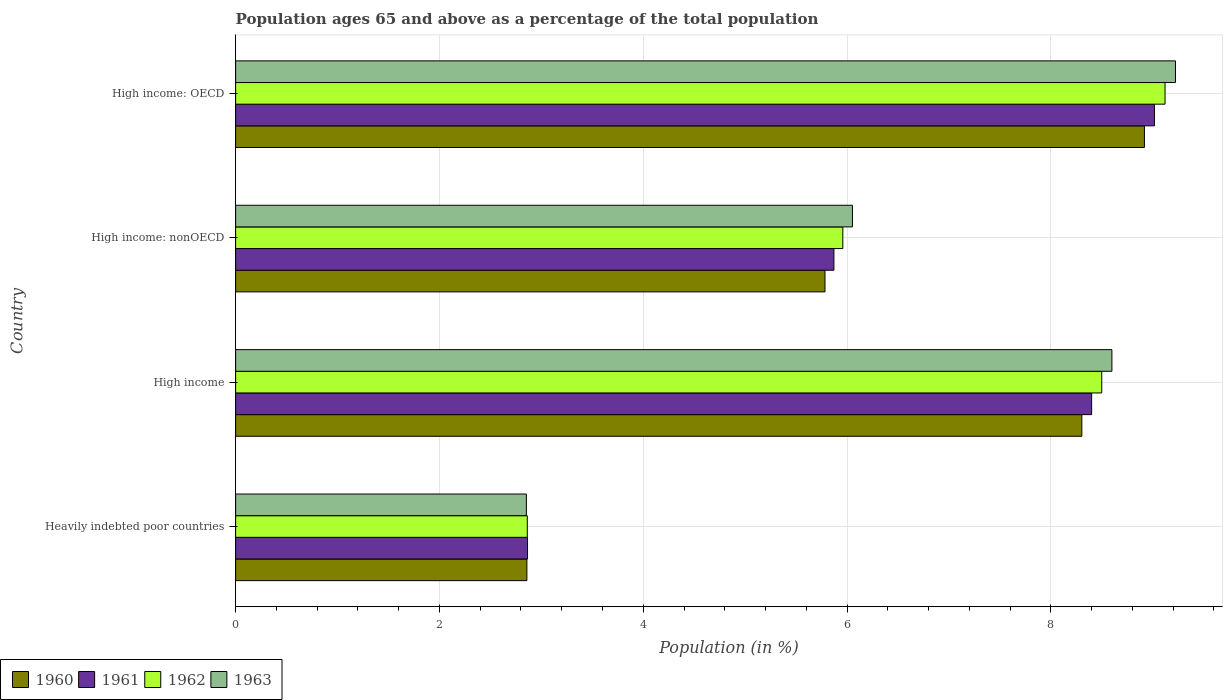Are the number of bars per tick equal to the number of legend labels?
Provide a succinct answer. Yes. Are the number of bars on each tick of the Y-axis equal?
Offer a very short reply. Yes. How many bars are there on the 2nd tick from the top?
Keep it short and to the point. 4. How many bars are there on the 3rd tick from the bottom?
Give a very brief answer. 4. What is the label of the 3rd group of bars from the top?
Make the answer very short. High income. What is the percentage of the population ages 65 and above in 1962 in High income: nonOECD?
Provide a succinct answer. 5.96. Across all countries, what is the maximum percentage of the population ages 65 and above in 1960?
Ensure brevity in your answer.  8.92. Across all countries, what is the minimum percentage of the population ages 65 and above in 1962?
Your answer should be compact. 2.86. In which country was the percentage of the population ages 65 and above in 1962 maximum?
Provide a short and direct response. High income: OECD. In which country was the percentage of the population ages 65 and above in 1963 minimum?
Offer a very short reply. Heavily indebted poor countries. What is the total percentage of the population ages 65 and above in 1962 in the graph?
Provide a succinct answer. 26.44. What is the difference between the percentage of the population ages 65 and above in 1960 in Heavily indebted poor countries and that in High income?
Provide a short and direct response. -5.45. What is the difference between the percentage of the population ages 65 and above in 1960 in High income and the percentage of the population ages 65 and above in 1963 in High income: nonOECD?
Your response must be concise. 2.25. What is the average percentage of the population ages 65 and above in 1960 per country?
Make the answer very short. 6.47. What is the difference between the percentage of the population ages 65 and above in 1960 and percentage of the population ages 65 and above in 1962 in High income: OECD?
Your response must be concise. -0.2. What is the ratio of the percentage of the population ages 65 and above in 1963 in High income to that in High income: OECD?
Your answer should be very brief. 0.93. Is the percentage of the population ages 65 and above in 1960 in High income: OECD less than that in High income: nonOECD?
Your answer should be compact. No. Is the difference between the percentage of the population ages 65 and above in 1960 in Heavily indebted poor countries and High income greater than the difference between the percentage of the population ages 65 and above in 1962 in Heavily indebted poor countries and High income?
Keep it short and to the point. Yes. What is the difference between the highest and the second highest percentage of the population ages 65 and above in 1963?
Provide a succinct answer. 0.62. What is the difference between the highest and the lowest percentage of the population ages 65 and above in 1963?
Offer a terse response. 6.37. In how many countries, is the percentage of the population ages 65 and above in 1961 greater than the average percentage of the population ages 65 and above in 1961 taken over all countries?
Ensure brevity in your answer.  2. Is it the case that in every country, the sum of the percentage of the population ages 65 and above in 1961 and percentage of the population ages 65 and above in 1963 is greater than the sum of percentage of the population ages 65 and above in 1960 and percentage of the population ages 65 and above in 1962?
Make the answer very short. No. Is it the case that in every country, the sum of the percentage of the population ages 65 and above in 1962 and percentage of the population ages 65 and above in 1960 is greater than the percentage of the population ages 65 and above in 1963?
Your answer should be compact. Yes. How many bars are there?
Offer a very short reply. 16. Are all the bars in the graph horizontal?
Ensure brevity in your answer.  Yes. How many countries are there in the graph?
Your response must be concise. 4. Does the graph contain grids?
Your answer should be very brief. Yes. How many legend labels are there?
Your answer should be very brief. 4. What is the title of the graph?
Provide a succinct answer. Population ages 65 and above as a percentage of the total population. Does "1960" appear as one of the legend labels in the graph?
Offer a terse response. Yes. What is the label or title of the X-axis?
Offer a terse response. Population (in %). What is the label or title of the Y-axis?
Your response must be concise. Country. What is the Population (in %) in 1960 in Heavily indebted poor countries?
Your answer should be compact. 2.86. What is the Population (in %) in 1961 in Heavily indebted poor countries?
Your answer should be compact. 2.86. What is the Population (in %) in 1962 in Heavily indebted poor countries?
Offer a very short reply. 2.86. What is the Population (in %) in 1963 in Heavily indebted poor countries?
Your answer should be very brief. 2.85. What is the Population (in %) in 1960 in High income?
Your answer should be compact. 8.3. What is the Population (in %) of 1961 in High income?
Your response must be concise. 8.4. What is the Population (in %) of 1962 in High income?
Offer a terse response. 8.5. What is the Population (in %) in 1963 in High income?
Ensure brevity in your answer.  8.6. What is the Population (in %) of 1960 in High income: nonOECD?
Keep it short and to the point. 5.78. What is the Population (in %) of 1961 in High income: nonOECD?
Your answer should be compact. 5.87. What is the Population (in %) of 1962 in High income: nonOECD?
Your answer should be very brief. 5.96. What is the Population (in %) in 1963 in High income: nonOECD?
Your answer should be compact. 6.05. What is the Population (in %) in 1960 in High income: OECD?
Give a very brief answer. 8.92. What is the Population (in %) of 1961 in High income: OECD?
Keep it short and to the point. 9.02. What is the Population (in %) in 1962 in High income: OECD?
Offer a very short reply. 9.12. What is the Population (in %) of 1963 in High income: OECD?
Provide a succinct answer. 9.22. Across all countries, what is the maximum Population (in %) of 1960?
Make the answer very short. 8.92. Across all countries, what is the maximum Population (in %) of 1961?
Your answer should be compact. 9.02. Across all countries, what is the maximum Population (in %) in 1962?
Offer a very short reply. 9.12. Across all countries, what is the maximum Population (in %) in 1963?
Offer a terse response. 9.22. Across all countries, what is the minimum Population (in %) in 1960?
Offer a very short reply. 2.86. Across all countries, what is the minimum Population (in %) in 1961?
Keep it short and to the point. 2.86. Across all countries, what is the minimum Population (in %) in 1962?
Give a very brief answer. 2.86. Across all countries, what is the minimum Population (in %) of 1963?
Make the answer very short. 2.85. What is the total Population (in %) of 1960 in the graph?
Your response must be concise. 25.86. What is the total Population (in %) in 1961 in the graph?
Your answer should be very brief. 26.15. What is the total Population (in %) of 1962 in the graph?
Give a very brief answer. 26.44. What is the total Population (in %) in 1963 in the graph?
Provide a short and direct response. 26.73. What is the difference between the Population (in %) of 1960 in Heavily indebted poor countries and that in High income?
Offer a terse response. -5.45. What is the difference between the Population (in %) of 1961 in Heavily indebted poor countries and that in High income?
Offer a terse response. -5.54. What is the difference between the Population (in %) of 1962 in Heavily indebted poor countries and that in High income?
Give a very brief answer. -5.64. What is the difference between the Population (in %) of 1963 in Heavily indebted poor countries and that in High income?
Give a very brief answer. -5.75. What is the difference between the Population (in %) of 1960 in Heavily indebted poor countries and that in High income: nonOECD?
Your answer should be compact. -2.92. What is the difference between the Population (in %) in 1961 in Heavily indebted poor countries and that in High income: nonOECD?
Your response must be concise. -3.01. What is the difference between the Population (in %) of 1962 in Heavily indebted poor countries and that in High income: nonOECD?
Your answer should be compact. -3.1. What is the difference between the Population (in %) of 1963 in Heavily indebted poor countries and that in High income: nonOECD?
Provide a short and direct response. -3.2. What is the difference between the Population (in %) of 1960 in Heavily indebted poor countries and that in High income: OECD?
Offer a terse response. -6.06. What is the difference between the Population (in %) of 1961 in Heavily indebted poor countries and that in High income: OECD?
Offer a terse response. -6.15. What is the difference between the Population (in %) in 1962 in Heavily indebted poor countries and that in High income: OECD?
Your answer should be compact. -6.26. What is the difference between the Population (in %) in 1963 in Heavily indebted poor countries and that in High income: OECD?
Give a very brief answer. -6.37. What is the difference between the Population (in %) in 1960 in High income and that in High income: nonOECD?
Keep it short and to the point. 2.52. What is the difference between the Population (in %) in 1961 in High income and that in High income: nonOECD?
Your answer should be very brief. 2.53. What is the difference between the Population (in %) in 1962 in High income and that in High income: nonOECD?
Your response must be concise. 2.54. What is the difference between the Population (in %) in 1963 in High income and that in High income: nonOECD?
Your answer should be compact. 2.55. What is the difference between the Population (in %) in 1960 in High income and that in High income: OECD?
Your answer should be compact. -0.61. What is the difference between the Population (in %) in 1961 in High income and that in High income: OECD?
Your answer should be very brief. -0.62. What is the difference between the Population (in %) of 1962 in High income and that in High income: OECD?
Give a very brief answer. -0.62. What is the difference between the Population (in %) in 1963 in High income and that in High income: OECD?
Make the answer very short. -0.62. What is the difference between the Population (in %) of 1960 in High income: nonOECD and that in High income: OECD?
Keep it short and to the point. -3.13. What is the difference between the Population (in %) of 1961 in High income: nonOECD and that in High income: OECD?
Your answer should be very brief. -3.15. What is the difference between the Population (in %) in 1962 in High income: nonOECD and that in High income: OECD?
Make the answer very short. -3.16. What is the difference between the Population (in %) in 1963 in High income: nonOECD and that in High income: OECD?
Keep it short and to the point. -3.17. What is the difference between the Population (in %) of 1960 in Heavily indebted poor countries and the Population (in %) of 1961 in High income?
Provide a short and direct response. -5.54. What is the difference between the Population (in %) of 1960 in Heavily indebted poor countries and the Population (in %) of 1962 in High income?
Offer a very short reply. -5.64. What is the difference between the Population (in %) in 1960 in Heavily indebted poor countries and the Population (in %) in 1963 in High income?
Offer a very short reply. -5.74. What is the difference between the Population (in %) in 1961 in Heavily indebted poor countries and the Population (in %) in 1962 in High income?
Offer a very short reply. -5.63. What is the difference between the Population (in %) of 1961 in Heavily indebted poor countries and the Population (in %) of 1963 in High income?
Ensure brevity in your answer.  -5.73. What is the difference between the Population (in %) in 1962 in Heavily indebted poor countries and the Population (in %) in 1963 in High income?
Offer a terse response. -5.74. What is the difference between the Population (in %) of 1960 in Heavily indebted poor countries and the Population (in %) of 1961 in High income: nonOECD?
Make the answer very short. -3.01. What is the difference between the Population (in %) of 1960 in Heavily indebted poor countries and the Population (in %) of 1962 in High income: nonOECD?
Give a very brief answer. -3.1. What is the difference between the Population (in %) of 1960 in Heavily indebted poor countries and the Population (in %) of 1963 in High income: nonOECD?
Provide a succinct answer. -3.19. What is the difference between the Population (in %) in 1961 in Heavily indebted poor countries and the Population (in %) in 1962 in High income: nonOECD?
Your answer should be compact. -3.09. What is the difference between the Population (in %) of 1961 in Heavily indebted poor countries and the Population (in %) of 1963 in High income: nonOECD?
Give a very brief answer. -3.19. What is the difference between the Population (in %) of 1962 in Heavily indebted poor countries and the Population (in %) of 1963 in High income: nonOECD?
Provide a short and direct response. -3.19. What is the difference between the Population (in %) in 1960 in Heavily indebted poor countries and the Population (in %) in 1961 in High income: OECD?
Provide a short and direct response. -6.16. What is the difference between the Population (in %) in 1960 in Heavily indebted poor countries and the Population (in %) in 1962 in High income: OECD?
Your answer should be very brief. -6.26. What is the difference between the Population (in %) of 1960 in Heavily indebted poor countries and the Population (in %) of 1963 in High income: OECD?
Provide a short and direct response. -6.36. What is the difference between the Population (in %) of 1961 in Heavily indebted poor countries and the Population (in %) of 1962 in High income: OECD?
Make the answer very short. -6.26. What is the difference between the Population (in %) of 1961 in Heavily indebted poor countries and the Population (in %) of 1963 in High income: OECD?
Keep it short and to the point. -6.36. What is the difference between the Population (in %) in 1962 in Heavily indebted poor countries and the Population (in %) in 1963 in High income: OECD?
Your answer should be very brief. -6.36. What is the difference between the Population (in %) of 1960 in High income and the Population (in %) of 1961 in High income: nonOECD?
Keep it short and to the point. 2.43. What is the difference between the Population (in %) of 1960 in High income and the Population (in %) of 1962 in High income: nonOECD?
Offer a terse response. 2.35. What is the difference between the Population (in %) in 1960 in High income and the Population (in %) in 1963 in High income: nonOECD?
Your answer should be very brief. 2.25. What is the difference between the Population (in %) of 1961 in High income and the Population (in %) of 1962 in High income: nonOECD?
Offer a very short reply. 2.44. What is the difference between the Population (in %) in 1961 in High income and the Population (in %) in 1963 in High income: nonOECD?
Provide a short and direct response. 2.35. What is the difference between the Population (in %) in 1962 in High income and the Population (in %) in 1963 in High income: nonOECD?
Ensure brevity in your answer.  2.45. What is the difference between the Population (in %) in 1960 in High income and the Population (in %) in 1961 in High income: OECD?
Offer a very short reply. -0.71. What is the difference between the Population (in %) of 1960 in High income and the Population (in %) of 1962 in High income: OECD?
Make the answer very short. -0.82. What is the difference between the Population (in %) of 1960 in High income and the Population (in %) of 1963 in High income: OECD?
Provide a succinct answer. -0.92. What is the difference between the Population (in %) in 1961 in High income and the Population (in %) in 1962 in High income: OECD?
Keep it short and to the point. -0.72. What is the difference between the Population (in %) in 1961 in High income and the Population (in %) in 1963 in High income: OECD?
Give a very brief answer. -0.82. What is the difference between the Population (in %) of 1962 in High income and the Population (in %) of 1963 in High income: OECD?
Your answer should be compact. -0.72. What is the difference between the Population (in %) of 1960 in High income: nonOECD and the Population (in %) of 1961 in High income: OECD?
Provide a succinct answer. -3.23. What is the difference between the Population (in %) of 1960 in High income: nonOECD and the Population (in %) of 1962 in High income: OECD?
Your response must be concise. -3.34. What is the difference between the Population (in %) in 1960 in High income: nonOECD and the Population (in %) in 1963 in High income: OECD?
Provide a succinct answer. -3.44. What is the difference between the Population (in %) in 1961 in High income: nonOECD and the Population (in %) in 1962 in High income: OECD?
Offer a terse response. -3.25. What is the difference between the Population (in %) in 1961 in High income: nonOECD and the Population (in %) in 1963 in High income: OECD?
Make the answer very short. -3.35. What is the difference between the Population (in %) in 1962 in High income: nonOECD and the Population (in %) in 1963 in High income: OECD?
Your answer should be very brief. -3.26. What is the average Population (in %) of 1960 per country?
Offer a terse response. 6.47. What is the average Population (in %) in 1961 per country?
Your answer should be very brief. 6.54. What is the average Population (in %) of 1962 per country?
Keep it short and to the point. 6.61. What is the average Population (in %) in 1963 per country?
Ensure brevity in your answer.  6.68. What is the difference between the Population (in %) in 1960 and Population (in %) in 1961 in Heavily indebted poor countries?
Provide a short and direct response. -0.01. What is the difference between the Population (in %) in 1960 and Population (in %) in 1962 in Heavily indebted poor countries?
Your answer should be compact. -0. What is the difference between the Population (in %) in 1960 and Population (in %) in 1963 in Heavily indebted poor countries?
Your response must be concise. 0.01. What is the difference between the Population (in %) in 1961 and Population (in %) in 1962 in Heavily indebted poor countries?
Ensure brevity in your answer.  0. What is the difference between the Population (in %) in 1961 and Population (in %) in 1963 in Heavily indebted poor countries?
Offer a terse response. 0.01. What is the difference between the Population (in %) of 1962 and Population (in %) of 1963 in Heavily indebted poor countries?
Make the answer very short. 0.01. What is the difference between the Population (in %) of 1960 and Population (in %) of 1961 in High income?
Ensure brevity in your answer.  -0.1. What is the difference between the Population (in %) of 1960 and Population (in %) of 1962 in High income?
Give a very brief answer. -0.2. What is the difference between the Population (in %) of 1960 and Population (in %) of 1963 in High income?
Your response must be concise. -0.3. What is the difference between the Population (in %) in 1961 and Population (in %) in 1962 in High income?
Your answer should be compact. -0.1. What is the difference between the Population (in %) of 1961 and Population (in %) of 1963 in High income?
Your answer should be compact. -0.2. What is the difference between the Population (in %) in 1962 and Population (in %) in 1963 in High income?
Offer a terse response. -0.1. What is the difference between the Population (in %) in 1960 and Population (in %) in 1961 in High income: nonOECD?
Make the answer very short. -0.09. What is the difference between the Population (in %) of 1960 and Population (in %) of 1962 in High income: nonOECD?
Your response must be concise. -0.18. What is the difference between the Population (in %) of 1960 and Population (in %) of 1963 in High income: nonOECD?
Make the answer very short. -0.27. What is the difference between the Population (in %) in 1961 and Population (in %) in 1962 in High income: nonOECD?
Provide a short and direct response. -0.09. What is the difference between the Population (in %) in 1961 and Population (in %) in 1963 in High income: nonOECD?
Your answer should be very brief. -0.18. What is the difference between the Population (in %) of 1962 and Population (in %) of 1963 in High income: nonOECD?
Provide a short and direct response. -0.09. What is the difference between the Population (in %) of 1960 and Population (in %) of 1961 in High income: OECD?
Offer a terse response. -0.1. What is the difference between the Population (in %) in 1960 and Population (in %) in 1962 in High income: OECD?
Your answer should be compact. -0.2. What is the difference between the Population (in %) of 1960 and Population (in %) of 1963 in High income: OECD?
Your answer should be very brief. -0.3. What is the difference between the Population (in %) in 1961 and Population (in %) in 1962 in High income: OECD?
Make the answer very short. -0.1. What is the difference between the Population (in %) in 1961 and Population (in %) in 1963 in High income: OECD?
Your answer should be compact. -0.21. What is the difference between the Population (in %) of 1962 and Population (in %) of 1963 in High income: OECD?
Offer a very short reply. -0.1. What is the ratio of the Population (in %) in 1960 in Heavily indebted poor countries to that in High income?
Provide a short and direct response. 0.34. What is the ratio of the Population (in %) in 1961 in Heavily indebted poor countries to that in High income?
Make the answer very short. 0.34. What is the ratio of the Population (in %) in 1962 in Heavily indebted poor countries to that in High income?
Offer a very short reply. 0.34. What is the ratio of the Population (in %) of 1963 in Heavily indebted poor countries to that in High income?
Make the answer very short. 0.33. What is the ratio of the Population (in %) in 1960 in Heavily indebted poor countries to that in High income: nonOECD?
Your answer should be very brief. 0.49. What is the ratio of the Population (in %) of 1961 in Heavily indebted poor countries to that in High income: nonOECD?
Offer a terse response. 0.49. What is the ratio of the Population (in %) of 1962 in Heavily indebted poor countries to that in High income: nonOECD?
Ensure brevity in your answer.  0.48. What is the ratio of the Population (in %) of 1963 in Heavily indebted poor countries to that in High income: nonOECD?
Offer a very short reply. 0.47. What is the ratio of the Population (in %) in 1960 in Heavily indebted poor countries to that in High income: OECD?
Offer a terse response. 0.32. What is the ratio of the Population (in %) in 1961 in Heavily indebted poor countries to that in High income: OECD?
Offer a terse response. 0.32. What is the ratio of the Population (in %) of 1962 in Heavily indebted poor countries to that in High income: OECD?
Make the answer very short. 0.31. What is the ratio of the Population (in %) of 1963 in Heavily indebted poor countries to that in High income: OECD?
Make the answer very short. 0.31. What is the ratio of the Population (in %) of 1960 in High income to that in High income: nonOECD?
Offer a terse response. 1.44. What is the ratio of the Population (in %) of 1961 in High income to that in High income: nonOECD?
Your answer should be compact. 1.43. What is the ratio of the Population (in %) of 1962 in High income to that in High income: nonOECD?
Your response must be concise. 1.43. What is the ratio of the Population (in %) in 1963 in High income to that in High income: nonOECD?
Provide a succinct answer. 1.42. What is the ratio of the Population (in %) of 1960 in High income to that in High income: OECD?
Keep it short and to the point. 0.93. What is the ratio of the Population (in %) of 1961 in High income to that in High income: OECD?
Your answer should be very brief. 0.93. What is the ratio of the Population (in %) in 1962 in High income to that in High income: OECD?
Make the answer very short. 0.93. What is the ratio of the Population (in %) in 1963 in High income to that in High income: OECD?
Ensure brevity in your answer.  0.93. What is the ratio of the Population (in %) of 1960 in High income: nonOECD to that in High income: OECD?
Provide a succinct answer. 0.65. What is the ratio of the Population (in %) of 1961 in High income: nonOECD to that in High income: OECD?
Give a very brief answer. 0.65. What is the ratio of the Population (in %) of 1962 in High income: nonOECD to that in High income: OECD?
Keep it short and to the point. 0.65. What is the ratio of the Population (in %) in 1963 in High income: nonOECD to that in High income: OECD?
Provide a succinct answer. 0.66. What is the difference between the highest and the second highest Population (in %) of 1960?
Offer a terse response. 0.61. What is the difference between the highest and the second highest Population (in %) in 1961?
Provide a short and direct response. 0.62. What is the difference between the highest and the second highest Population (in %) in 1962?
Your answer should be very brief. 0.62. What is the difference between the highest and the second highest Population (in %) in 1963?
Provide a succinct answer. 0.62. What is the difference between the highest and the lowest Population (in %) of 1960?
Keep it short and to the point. 6.06. What is the difference between the highest and the lowest Population (in %) in 1961?
Your response must be concise. 6.15. What is the difference between the highest and the lowest Population (in %) in 1962?
Your response must be concise. 6.26. What is the difference between the highest and the lowest Population (in %) in 1963?
Provide a succinct answer. 6.37. 